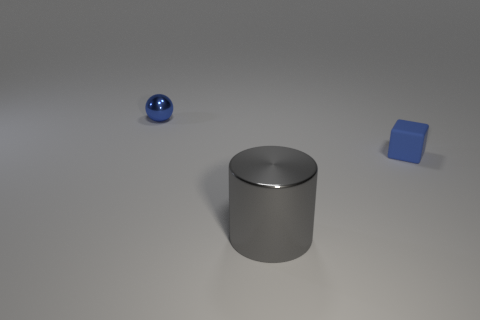How big is the thing that is on the left side of the rubber cube and behind the large gray cylinder?
Your response must be concise. Small. What is the shape of the tiny metallic thing that is the same color as the tiny matte thing?
Your answer should be very brief. Sphere. How many other gray objects are made of the same material as the large object?
Your answer should be very brief. 0. There is a object that is both behind the large thing and in front of the blue ball; what shape is it?
Ensure brevity in your answer.  Cube. Are the blue thing that is to the left of the big gray metal cylinder and the gray thing made of the same material?
Ensure brevity in your answer.  Yes. Are there any other things that are the same material as the block?
Your response must be concise. No. There is a block that is the same size as the blue metallic thing; what is its color?
Provide a short and direct response. Blue. Is there a tiny matte cube that has the same color as the tiny ball?
Offer a terse response. Yes. There is a cylinder that is the same material as the tiny ball; what is its size?
Keep it short and to the point. Large. What is the size of the object that is the same color as the metallic sphere?
Offer a terse response. Small. 